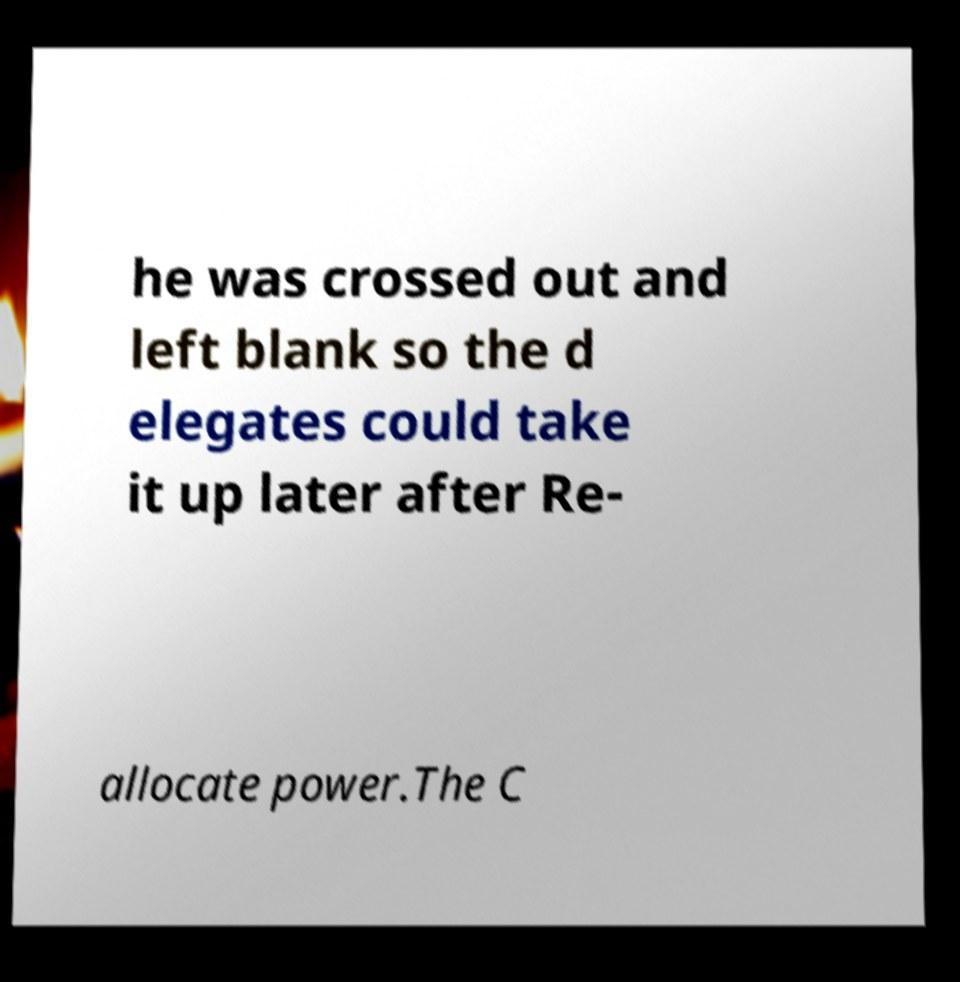There's text embedded in this image that I need extracted. Can you transcribe it verbatim? he was crossed out and left blank so the d elegates could take it up later after Re- allocate power.The C 